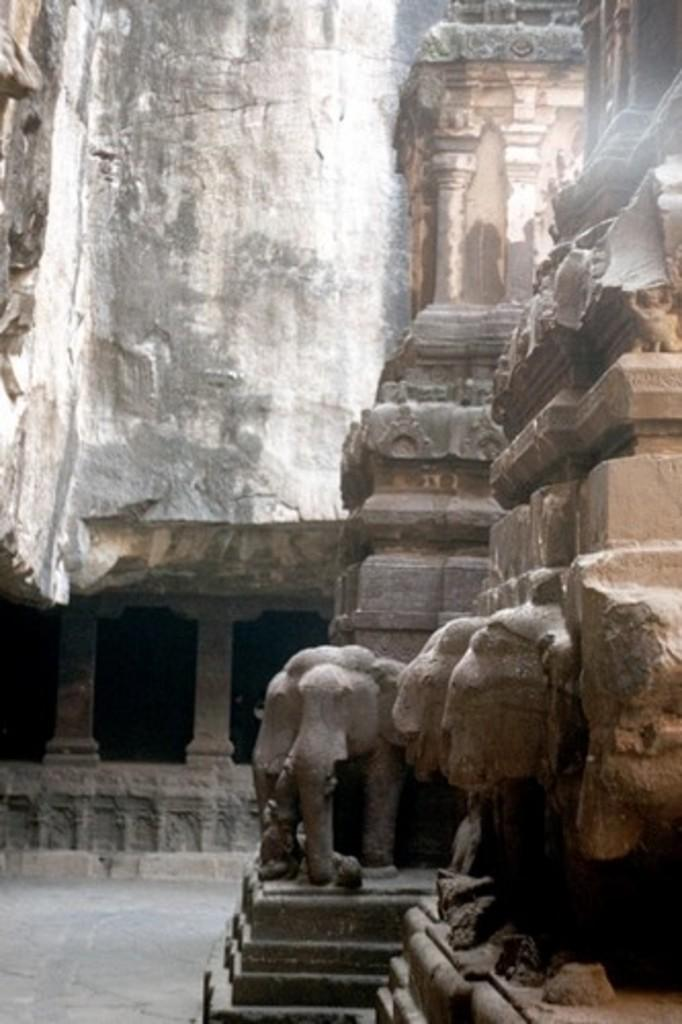What type of structure can be seen in the image? There is a wall in the image. What decorative elements are present on the wall? There are sculptures of an animal in the image. What is the name of the owl that is supporting the wall in the image? There is no owl present in the image, and the wall is not being supported by any animal. 